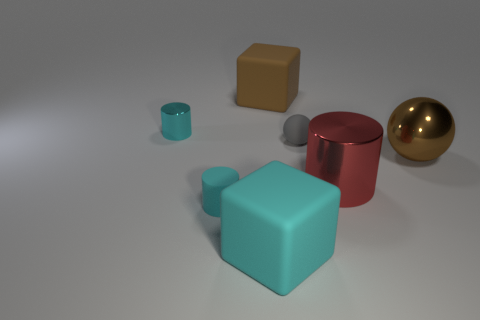Subtract all cyan cylinders. How many cylinders are left? 1 Subtract all yellow spheres. How many cyan cylinders are left? 2 Add 2 tiny cylinders. How many objects exist? 9 Subtract all brown blocks. How many blocks are left? 1 Subtract all purple spheres. Subtract all yellow blocks. How many spheres are left? 2 Subtract all small cyan shiny objects. Subtract all cyan rubber cylinders. How many objects are left? 5 Add 3 tiny rubber objects. How many tiny rubber objects are left? 5 Add 7 cyan cylinders. How many cyan cylinders exist? 9 Subtract 0 brown cylinders. How many objects are left? 7 Subtract all cylinders. How many objects are left? 4 